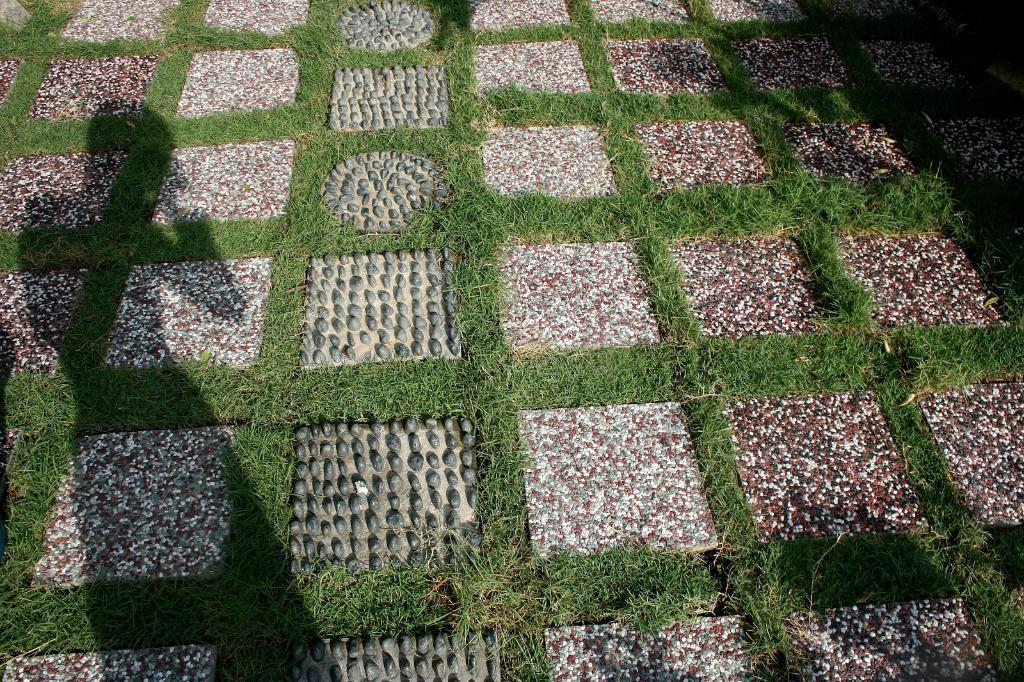What type of surface is visible in the image? There is a pavement in the image. What type of vegetation can be seen in the image? There is grass visible in the image. How many plants are visible in the image? There is no specific number of plants mentioned in the facts, but there is grass visible in the image. Can you tell me how many people are present in the crowd in the image? There is no mention of a crowd or any people in the image; it only features a pavement and grass. 